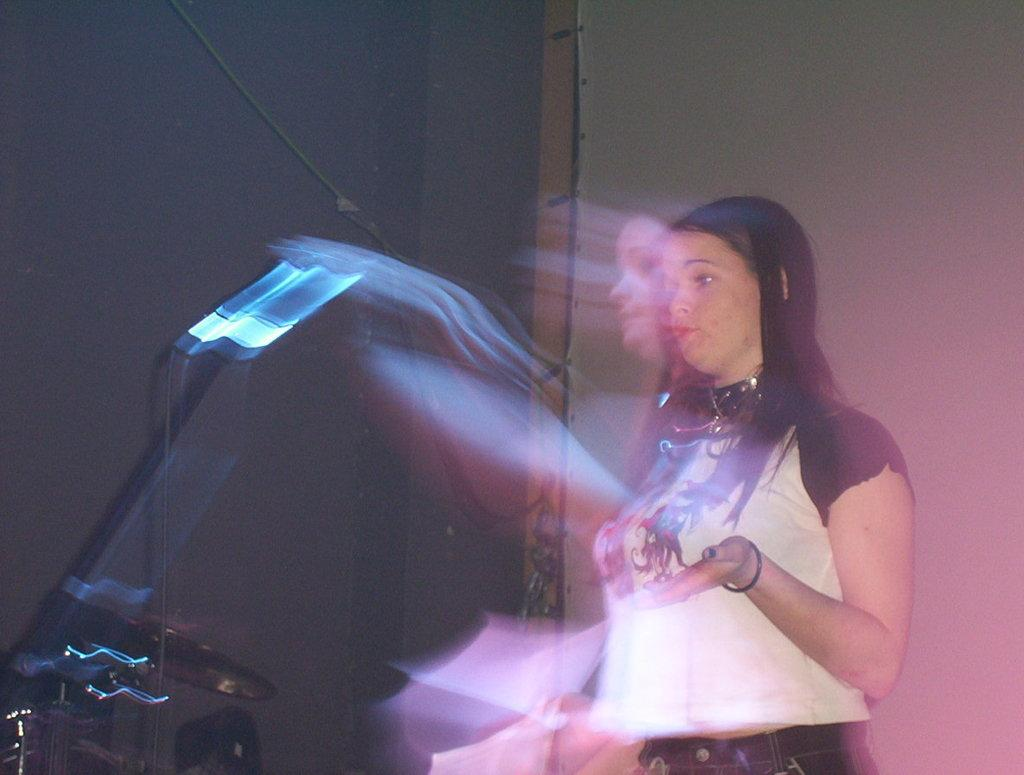What is the main subject of the image? There is a person in the image. What is in front of the person? There are objects in front of the person. What is behind the person? There is a wall behind the person. the person. What time of day is the hen depicted in the image? There is no hen present in the image. Who is the creator of the person in the image? The image is a photograph or illustration, not a creation by a specific person. 